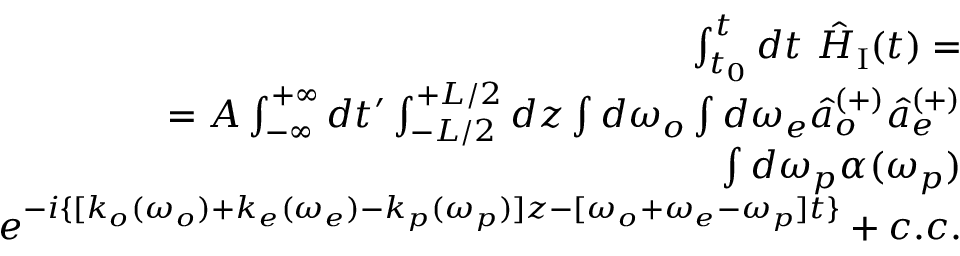Convert formula to latex. <formula><loc_0><loc_0><loc_500><loc_500>\begin{array} { r } { \int _ { t _ { 0 } } ^ { t } d t \hat { H } _ { I } ( t ) = } \\ { = A \int _ { - \infty } ^ { + \infty } d t ^ { \prime } \int _ { - L / 2 } ^ { + L / 2 } d z \int d \omega _ { o } \int d \omega _ { e } \hat { a } _ { o } ^ { ( + ) } \hat { a } _ { e } ^ { ( + ) } } \\ { \int d \omega _ { p } \alpha ( \omega _ { p } ) } \\ { e ^ { - i \{ [ k _ { o } ( \omega _ { o } ) + k _ { e } ( \omega _ { e } ) - k _ { p } ( \omega _ { p } ) ] z - [ \omega _ { o } + \omega _ { e } - \omega _ { p } ] t \} } + c . c . } \end{array}</formula> 